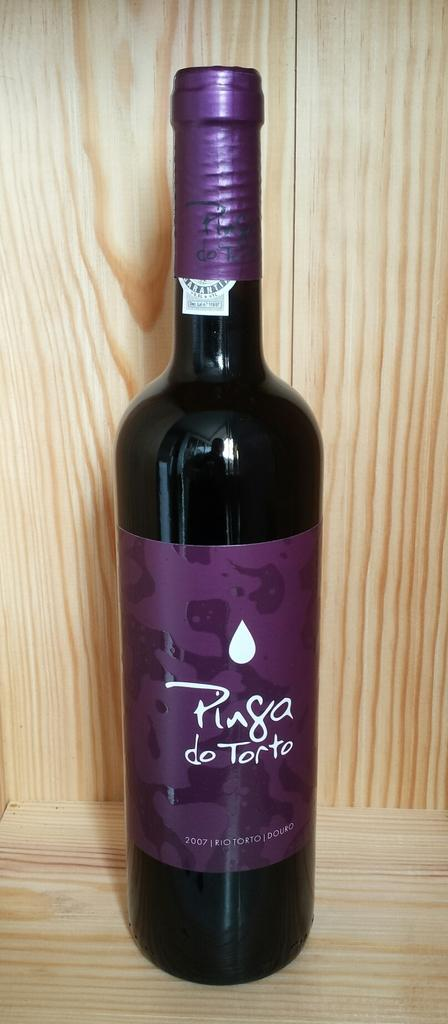<image>
Share a concise interpretation of the image provided. Pinga torto purple bottle that never been open 